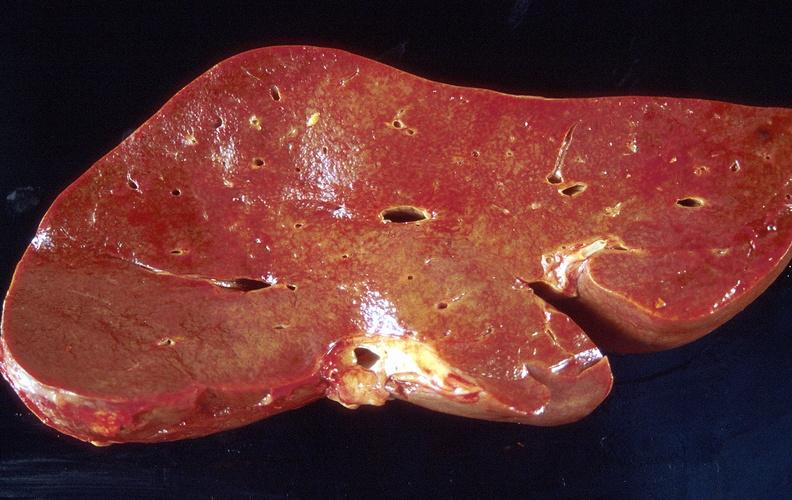what does this image show?
Answer the question using a single word or phrase. Amyloid 